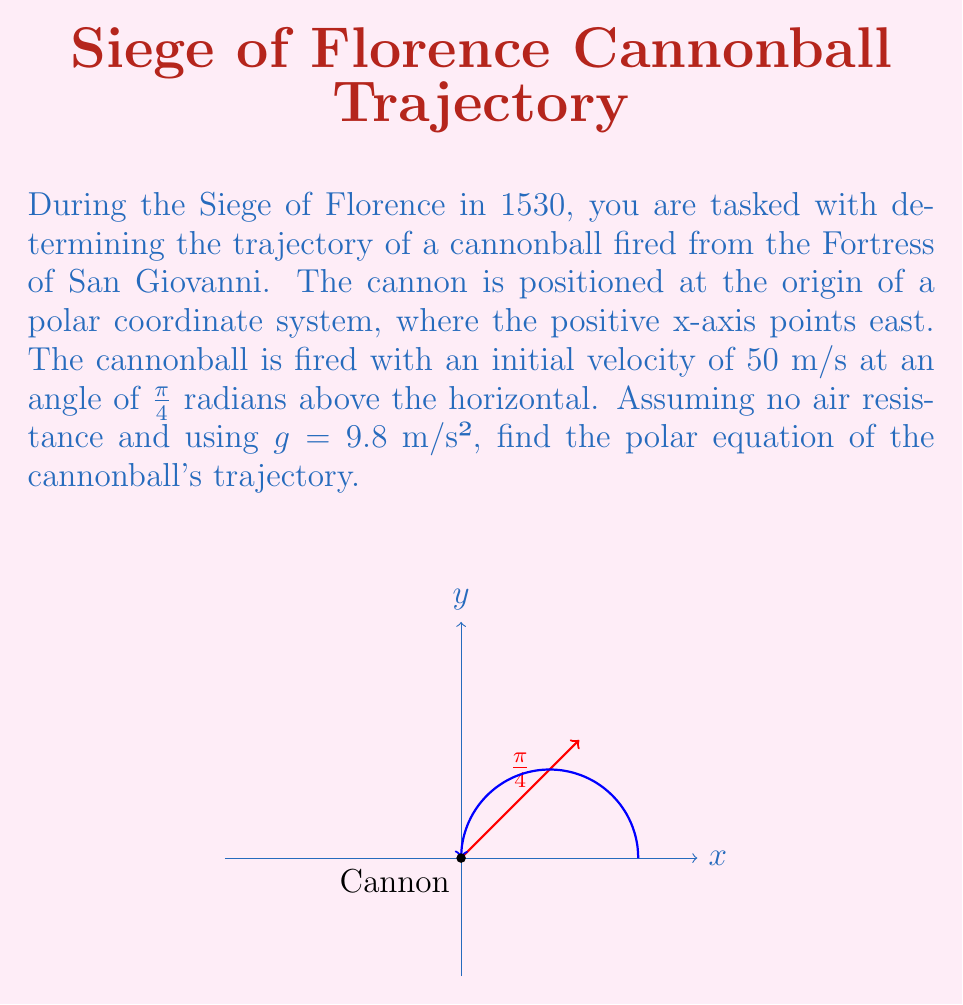Can you answer this question? Let's approach this step-by-step:

1) In polar coordinates, we can express the position of the cannonball as:
   $r = r(\theta)$

2) The initial velocity components are:
   $v_x = v_0 \cos(\pi/4) = 50 \cdot \frac{\sqrt{2}}{2} \approx 35.36$ m/s
   $v_y = v_0 \sin(\pi/4) = 50 \cdot \frac{\sqrt{2}}{2} \approx 35.36$ m/s

3) The parametric equations of motion in Cartesian coordinates are:
   $x = v_x t = 35.36t$
   $y = v_y t - \frac{1}{2}gt^2 = 35.36t - 4.9t^2$

4) To convert to polar coordinates, we use the relations:
   $x = r \cos(\theta)$
   $y = r \sin(\theta)$

5) Dividing y by x:
   $\tan(\theta) = \frac{y}{x} = \frac{35.36t - 4.9t^2}{35.36t} = 1 - \frac{4.9t}{35.36}$

6) Solving for t:
   $t = \frac{35.36(1-\tan(\theta))}{4.9} \approx 7.22(1-\tan(\theta))$

7) Substituting this back into the equation for x:
   $x = 35.36 \cdot 7.22(1-\tan(\theta)) = 255(1-\tan(\theta))$

8) Since $x = r \cos(\theta)$, we have:
   $r \cos(\theta) = 255(1-\tan(\theta))$

9) Dividing both sides by $\cos(\theta)$:
   $r = \frac{255(1-\tan(\theta))}{\cos(\theta)} = \frac{255(\cos(\theta)-\sin(\theta))}{\cos^2(\theta)}$

10) Simplifying:
    $r = \frac{255}{\cos(\theta)} - 255\tan(\theta) = \frac{255}{\cos(\theta)} - \frac{255\sin(\theta)}{\cos(\theta)} = \frac{255}{\cos^2(\theta)}$

Therefore, the polar equation of the trajectory is:
$$r = \frac{255}{\cos^2(\theta)}$$
Answer: $r = \frac{255}{\cos^2(\theta)}$ 